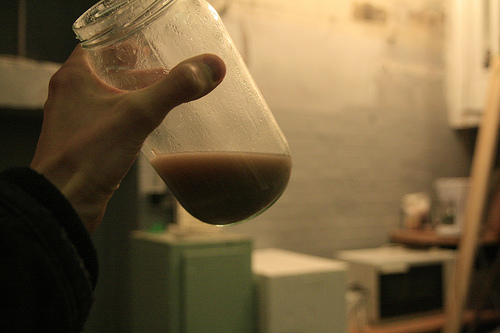<image>
Is the thumb above the jar? No. The thumb is not positioned above the jar. The vertical arrangement shows a different relationship. Is there a wall behind the jar? Yes. From this viewpoint, the wall is positioned behind the jar, with the jar partially or fully occluding the wall. 